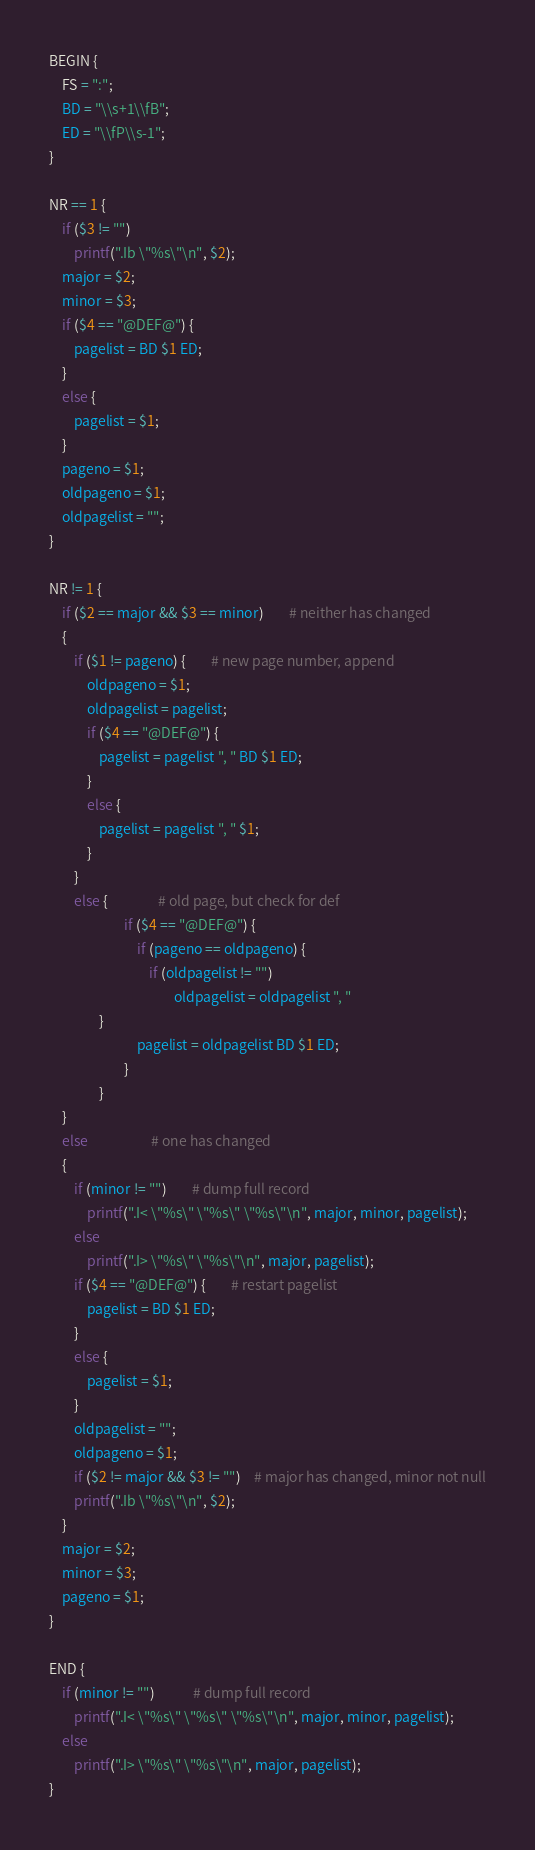<code> <loc_0><loc_0><loc_500><loc_500><_Awk_>BEGIN {
	FS = ":";
	BD = "\\s+1\\fB";
	ED = "\\fP\\s-1";
}

NR == 1 {
	if ($3 != "")
		printf(".Ib \"%s\"\n", $2);
	major = $2;
	minor = $3;
	if ($4 == "@DEF@") {
		pagelist = BD $1 ED;
	}
	else {
		pagelist = $1;
	}
	pageno = $1;
	oldpageno = $1;
	oldpagelist = "";
}

NR != 1 {
	if ($2 == major && $3 == minor)		# neither has changed
	{
		if ($1 != pageno) {		# new page number, append
			oldpageno = $1;
			oldpagelist = pagelist;
			if ($4 == "@DEF@") {
				pagelist = pagelist ", " BD $1 ED;
			}
			else {
				pagelist = pagelist ", " $1;
			}
		}
		else {				# old page, but check for def
               	        if ($4 == "@DEF@") {
                            if (pageno == oldpageno) {
                                if (oldpagelist != "")
                                        oldpagelist = oldpagelist ", "
			    }
                            pagelist = oldpagelist BD $1 ED;
                        }
                }
	}
	else					# one has changed
	{
		if (minor != "")		# dump full record
			printf(".I< \"%s\" \"%s\" \"%s\"\n", major, minor, pagelist);
		else
			printf(".I> \"%s\" \"%s\"\n", major, pagelist);
		if ($4 == "@DEF@") {		# restart pagelist
			pagelist = BD $1 ED;
		}
		else {
			pagelist = $1;
		}
		oldpagelist = "";
		oldpageno = $1;
		if ($2 != major && $3 != "")	# major has changed, minor not null
		printf(".Ib \"%s\"\n", $2);
	}
	major = $2;
	minor = $3;
	pageno = $1;
}

END {
	if (minor != "")			# dump full record
		printf(".I< \"%s\" \"%s\" \"%s\"\n", major, minor, pagelist);
	else
		printf(".I> \"%s\" \"%s\"\n", major, pagelist);
}
</code> 